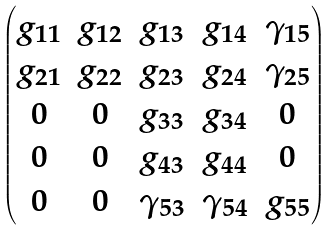Convert formula to latex. <formula><loc_0><loc_0><loc_500><loc_500>\begin{pmatrix} g _ { 1 1 } & g _ { 1 2 } & g _ { 1 3 } & g _ { 1 4 } & \gamma _ { 1 5 } \\ g _ { 2 1 } & g _ { 2 2 } & g _ { 2 3 } & g _ { 2 4 } & \gamma _ { 2 5 } \\ 0 & 0 & g _ { 3 3 } & g _ { 3 4 } & 0 \\ 0 & 0 & g _ { 4 3 } & g _ { 4 4 } & 0 \\ 0 & 0 & \gamma _ { 5 3 } & \gamma _ { 5 4 } & g _ { 5 5 } \\ \end{pmatrix}</formula> 